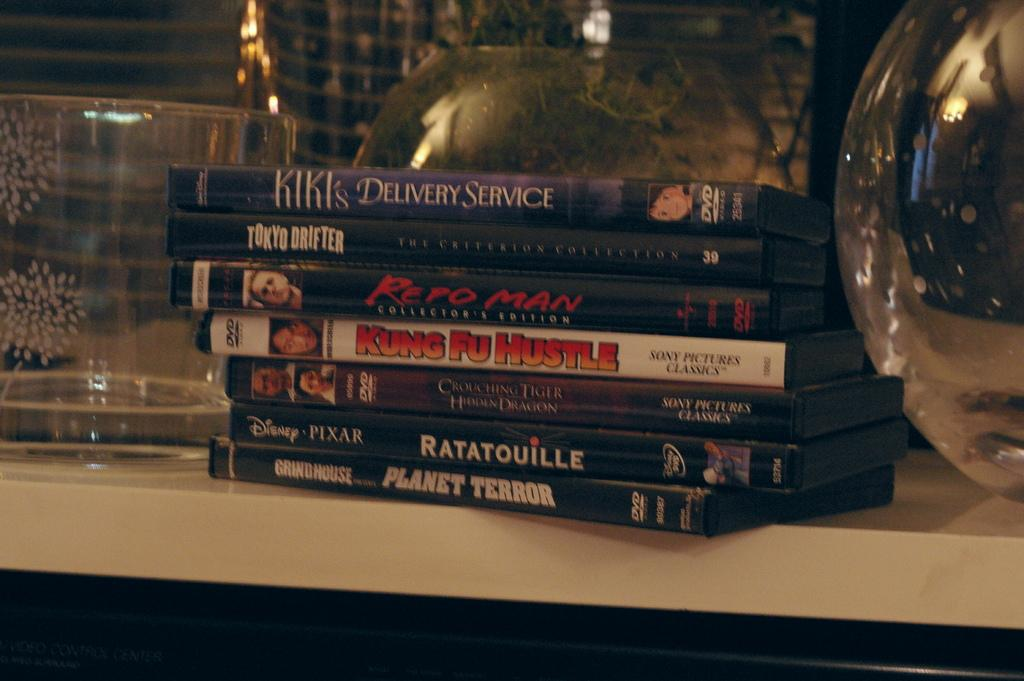<image>
Write a terse but informative summary of the picture. A collection of DVDs sits on a shelf and includes the title Kung Fu Hustle. 